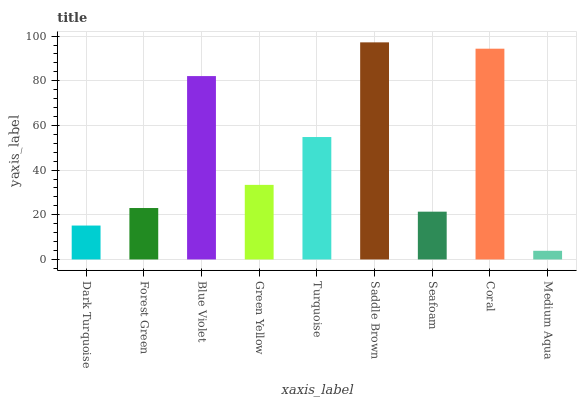Is Medium Aqua the minimum?
Answer yes or no. Yes. Is Saddle Brown the maximum?
Answer yes or no. Yes. Is Forest Green the minimum?
Answer yes or no. No. Is Forest Green the maximum?
Answer yes or no. No. Is Forest Green greater than Dark Turquoise?
Answer yes or no. Yes. Is Dark Turquoise less than Forest Green?
Answer yes or no. Yes. Is Dark Turquoise greater than Forest Green?
Answer yes or no. No. Is Forest Green less than Dark Turquoise?
Answer yes or no. No. Is Green Yellow the high median?
Answer yes or no. Yes. Is Green Yellow the low median?
Answer yes or no. Yes. Is Seafoam the high median?
Answer yes or no. No. Is Coral the low median?
Answer yes or no. No. 